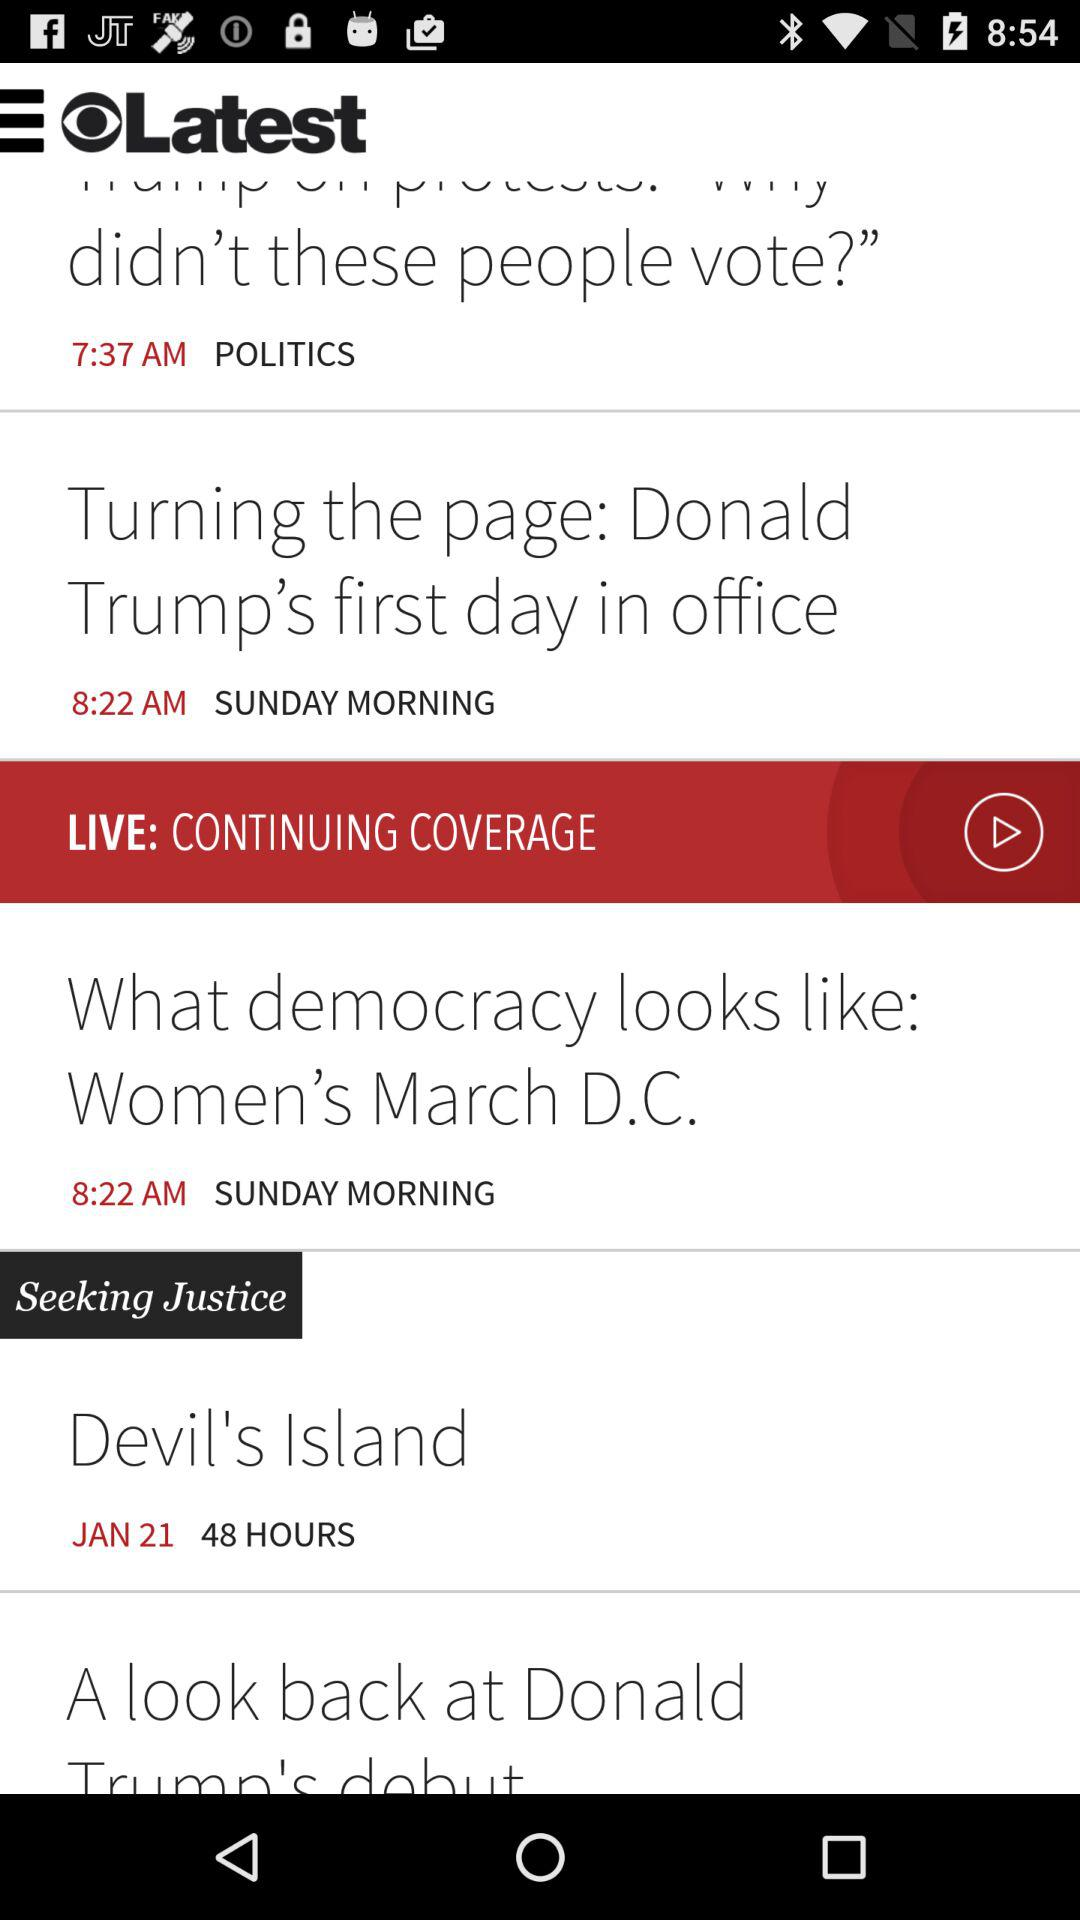What was published by "SUNDAY MORNING"? The articles "Turning the page: Donald Trump's first day in office" and "What democracy looks like: Women's March D.C." were published by "SUNDAY MORNING". 